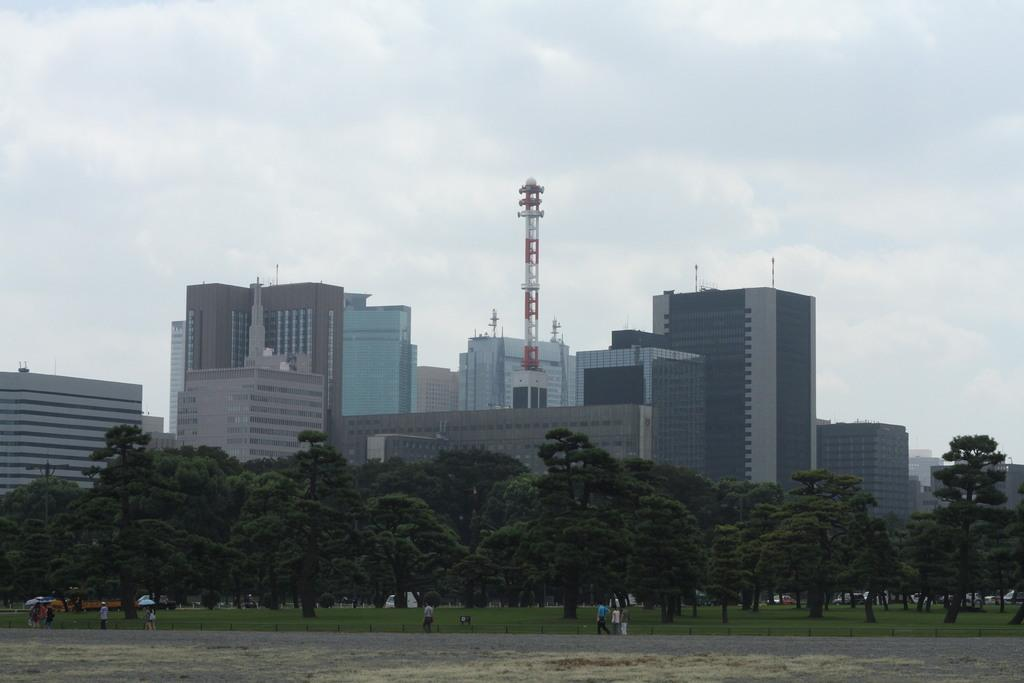What are the people in the image doing? The people in the image are walking on a road. What can be seen in the background of the image? There are trees and buildings in the background of the image. How would you describe the sky in the image? The sky is cloudy in the background of the image. What type of wall can be seen in the image? There is no wall present in the image. What attraction is visible in the background of the image? There is no attraction visible in the image; only trees, buildings, and the sky are present. 